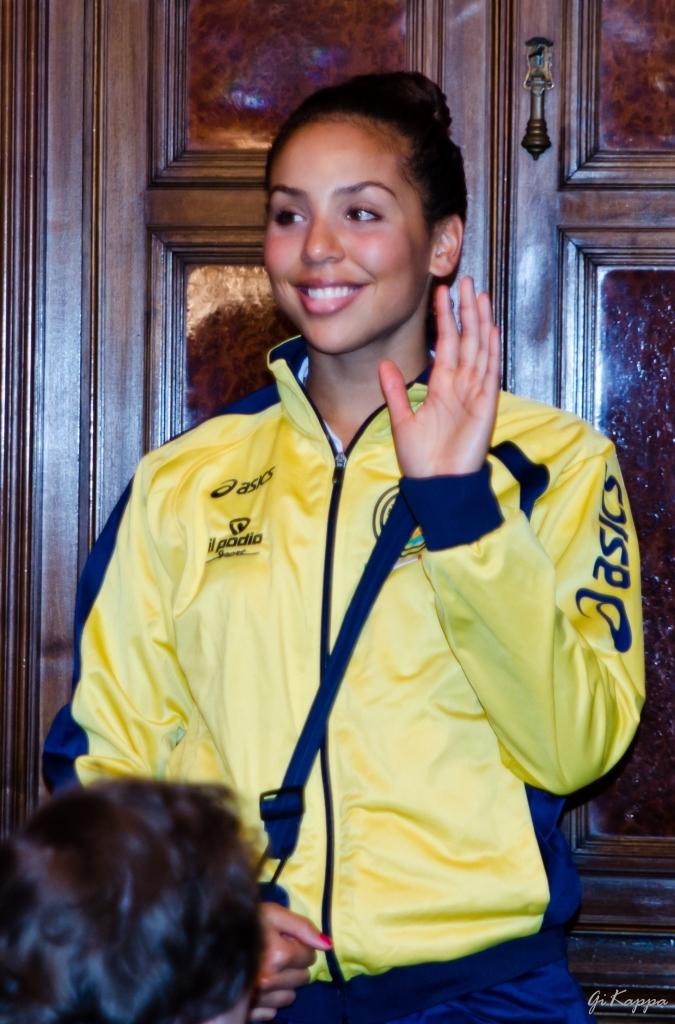What brand is the yellow jacket?
Provide a short and direct response. Asics. Does the yellow jacket contain black text?
Make the answer very short. Yes. 